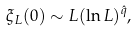<formula> <loc_0><loc_0><loc_500><loc_500>\xi _ { L } ( 0 ) \sim L ( \ln { L } ) ^ { \hat { q } } ,</formula> 